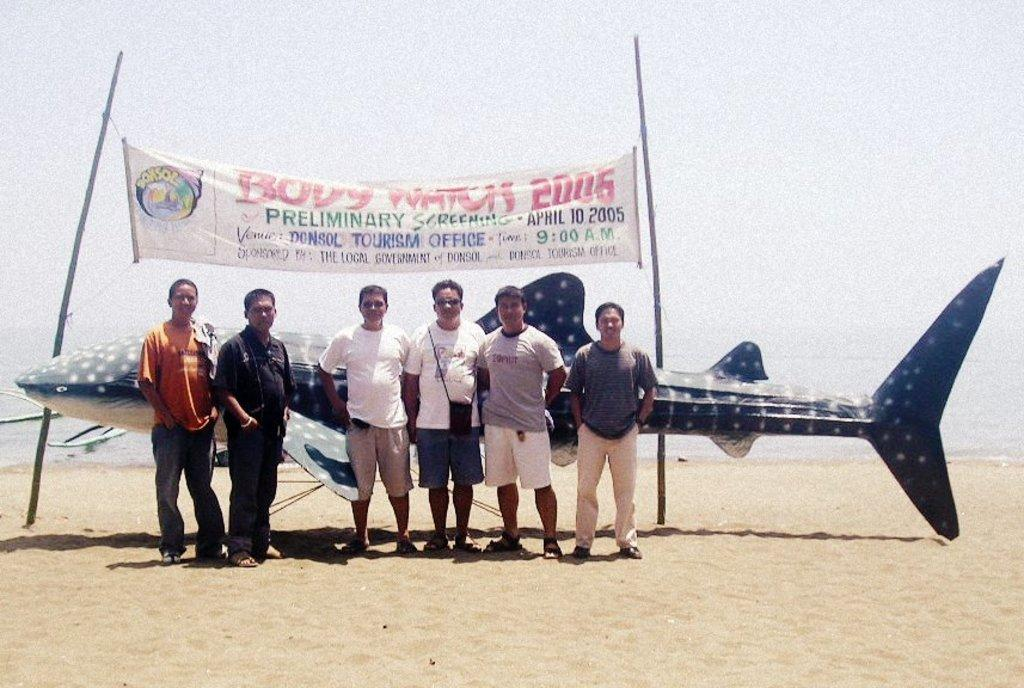<image>
Create a compact narrative representing the image presented. A group of men are posing by a large fake shark under a sign that says Body Watch 2006.. 